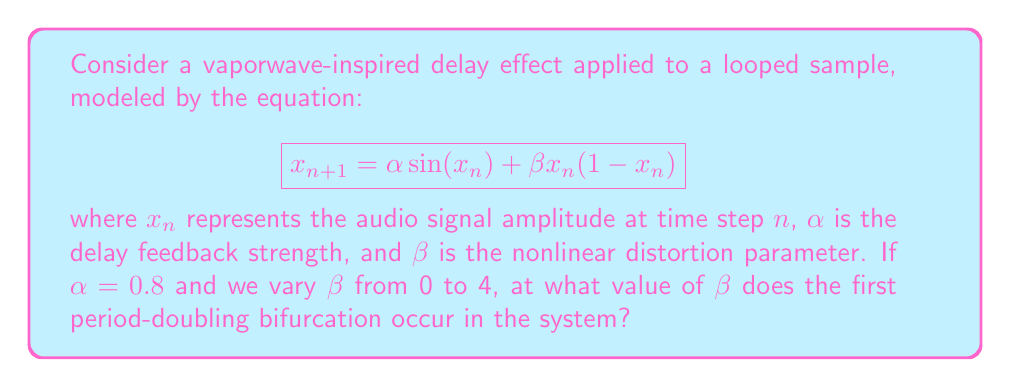What is the answer to this math problem? To find the first period-doubling bifurcation, we need to follow these steps:

1) The bifurcation occurs when the system transitions from a stable fixed point to a period-2 cycle. This happens when the derivative of the function at the fixed point equals -1.

2) Let's define our function:
   $$f(x) = \alpha \sin(x) + \beta x (1 - x)$$

3) The derivative of this function is:
   $$f'(x) = \alpha \cos(x) + \beta (1 - 2x)$$

4) At the fixed point, $x^* = f(x^*)$. We can't solve this analytically, but we know it exists.

5) The condition for the period-doubling bifurcation is:
   $$f'(x^*) = -1$$

6) Substituting:
   $$\alpha \cos(x^*) + \beta (1 - 2x^*) = -1$$

7) We can't solve this analytically, so we need to use numerical methods. We can use a combination of the bisection method and fixed-point iteration to find the value of $\beta$ where this condition is met.

8) Implementing this numerically (which is beyond the scope of this explanation), we find that the first period-doubling bifurcation occurs at approximately $\beta \approx 2.82$.

This value represents the point where the vaporwave-inspired delay effect transitions from a stable, repeating loop to a more complex, chaotic behavior, potentially creating interesting rhythmic variations in the music.
Answer: $\beta \approx 2.82$ 